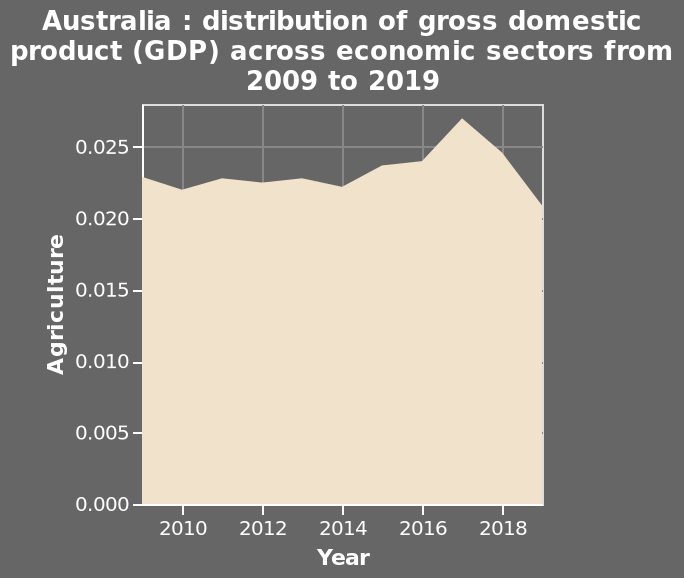<image>
What is the overall time period covered by the data in the chart? The data in the chart covers the years from 2009 to 2019. Has the agriculture sector's contribution to GDP been fluctuating after 2015?  No, the share of GDP contributed by the agriculture sector has steadily declined after 2015. When did the decline in the share of GDP contributed by the agriculture sector begin?  The decline in the share of GDP contributed by the agriculture sector began in 2017. What has happened to the share of GDP contributed by the agriculture sector since 2017?  The share of GDP contributed by the agriculture sector has declined significantly since 2017. 